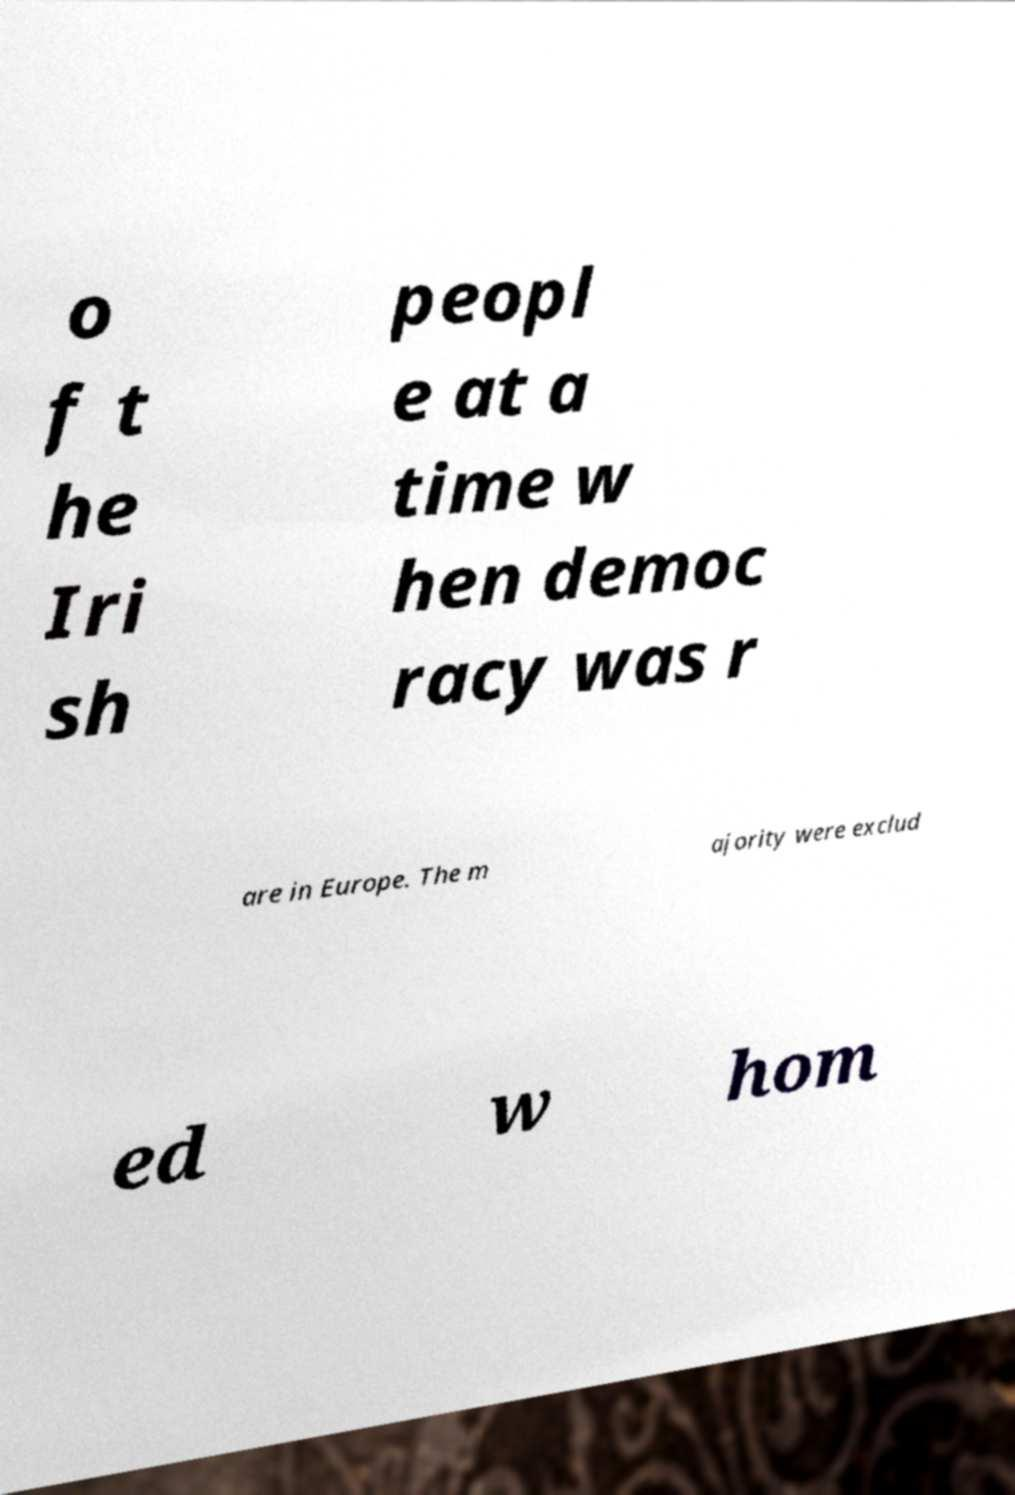Please read and relay the text visible in this image. What does it say? o f t he Iri sh peopl e at a time w hen democ racy was r are in Europe. The m ajority were exclud ed w hom 